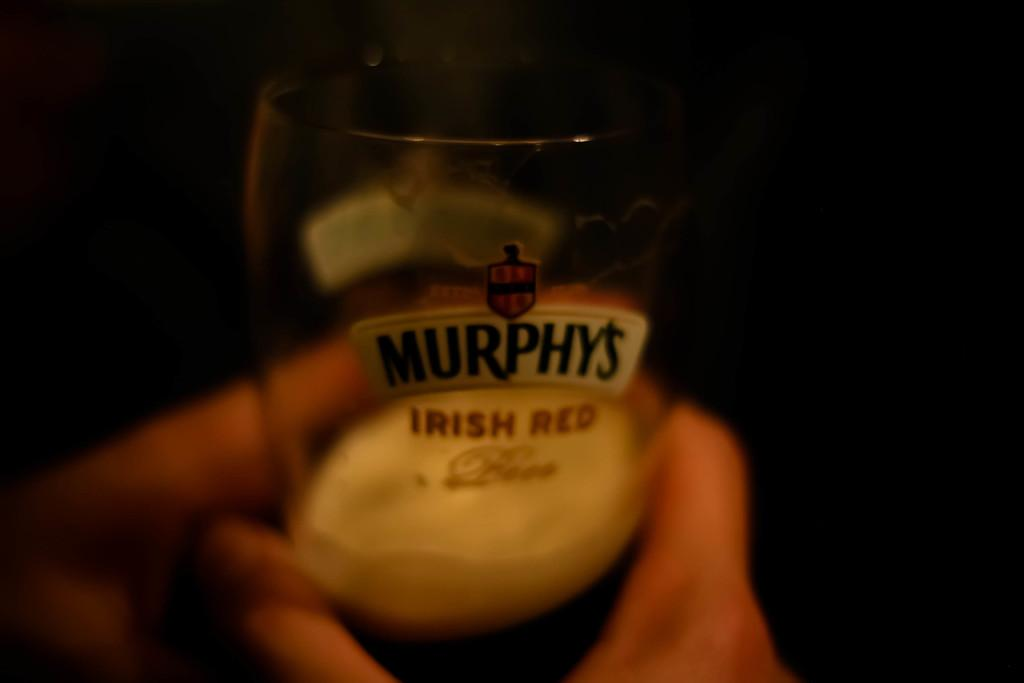<image>
Provide a brief description of the given image. a shot glass labeled with the logo of "Murphys Irish Red" 